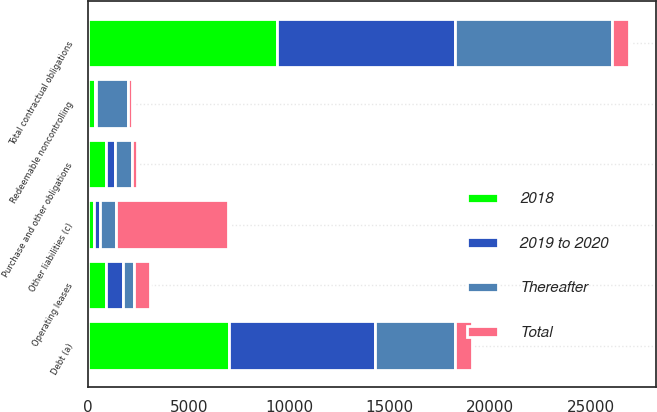<chart> <loc_0><loc_0><loc_500><loc_500><stacked_bar_chart><ecel><fcel>Debt (a)<fcel>Operating leases<fcel>Purchase and other obligations<fcel>Other liabilities (c)<fcel>Redeemable noncontrolling<fcel>Total contractual obligations<nl><fcel>Thereafter<fcel>4006<fcel>538<fcel>833<fcel>823<fcel>1575<fcel>7775<nl><fcel>2018<fcel>7017<fcel>884<fcel>866<fcel>284<fcel>358<fcel>9409<nl><fcel>2019 to 2020<fcel>7241<fcel>851<fcel>462<fcel>284<fcel>25<fcel>8863<nl><fcel>Total<fcel>842<fcel>809<fcel>293<fcel>5589<fcel>231<fcel>842<nl></chart> 